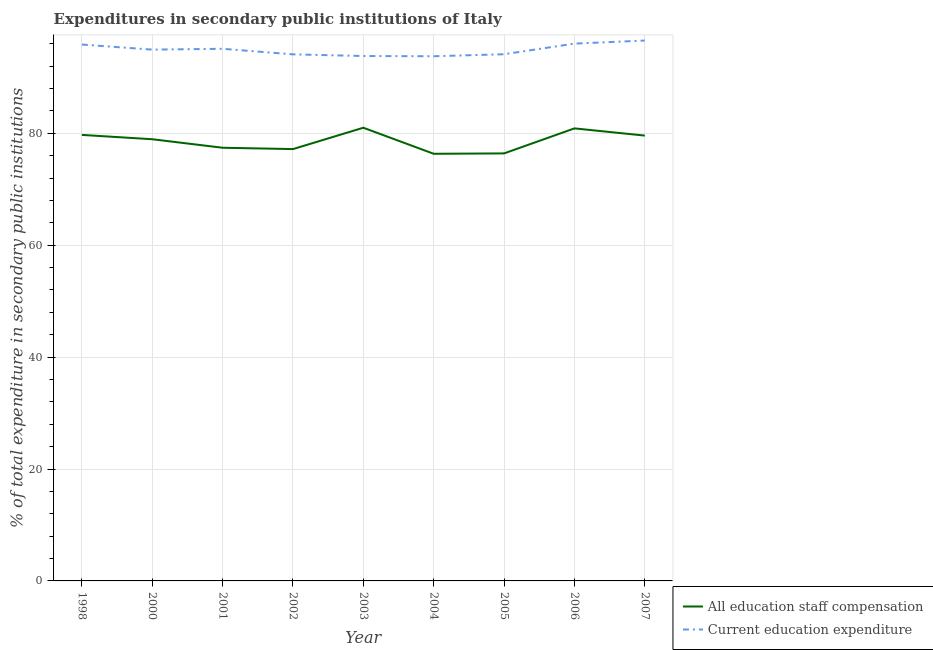Is the number of lines equal to the number of legend labels?
Keep it short and to the point. Yes. What is the expenditure in staff compensation in 2004?
Your response must be concise. 76.35. Across all years, what is the maximum expenditure in staff compensation?
Your answer should be very brief. 81. Across all years, what is the minimum expenditure in education?
Make the answer very short. 93.78. What is the total expenditure in staff compensation in the graph?
Make the answer very short. 707.53. What is the difference between the expenditure in staff compensation in 2001 and that in 2004?
Your answer should be compact. 1.08. What is the difference between the expenditure in staff compensation in 2004 and the expenditure in education in 2005?
Provide a short and direct response. -17.79. What is the average expenditure in staff compensation per year?
Offer a terse response. 78.61. In the year 2005, what is the difference between the expenditure in education and expenditure in staff compensation?
Your answer should be very brief. 17.73. What is the ratio of the expenditure in staff compensation in 2004 to that in 2006?
Offer a very short reply. 0.94. What is the difference between the highest and the second highest expenditure in education?
Provide a short and direct response. 0.55. What is the difference between the highest and the lowest expenditure in staff compensation?
Offer a terse response. 4.66. Is the sum of the expenditure in staff compensation in 2003 and 2007 greater than the maximum expenditure in education across all years?
Make the answer very short. Yes. Is the expenditure in education strictly greater than the expenditure in staff compensation over the years?
Provide a succinct answer. Yes. How many lines are there?
Provide a short and direct response. 2. What is the difference between two consecutive major ticks on the Y-axis?
Your response must be concise. 20. What is the title of the graph?
Offer a very short reply. Expenditures in secondary public institutions of Italy. What is the label or title of the Y-axis?
Provide a succinct answer. % of total expenditure in secondary public institutions. What is the % of total expenditure in secondary public institutions of All education staff compensation in 1998?
Keep it short and to the point. 79.72. What is the % of total expenditure in secondary public institutions of Current education expenditure in 1998?
Give a very brief answer. 95.87. What is the % of total expenditure in secondary public institutions in All education staff compensation in 2000?
Make the answer very short. 78.95. What is the % of total expenditure in secondary public institutions in Current education expenditure in 2000?
Give a very brief answer. 94.97. What is the % of total expenditure in secondary public institutions in All education staff compensation in 2001?
Your response must be concise. 77.43. What is the % of total expenditure in secondary public institutions of Current education expenditure in 2001?
Keep it short and to the point. 95.11. What is the % of total expenditure in secondary public institutions of All education staff compensation in 2002?
Offer a very short reply. 77.19. What is the % of total expenditure in secondary public institutions in Current education expenditure in 2002?
Keep it short and to the point. 94.12. What is the % of total expenditure in secondary public institutions of All education staff compensation in 2003?
Provide a short and direct response. 81. What is the % of total expenditure in secondary public institutions in Current education expenditure in 2003?
Provide a succinct answer. 93.82. What is the % of total expenditure in secondary public institutions of All education staff compensation in 2004?
Provide a succinct answer. 76.35. What is the % of total expenditure in secondary public institutions in Current education expenditure in 2004?
Offer a terse response. 93.78. What is the % of total expenditure in secondary public institutions of All education staff compensation in 2005?
Offer a terse response. 76.41. What is the % of total expenditure in secondary public institutions in Current education expenditure in 2005?
Your answer should be compact. 94.14. What is the % of total expenditure in secondary public institutions in All education staff compensation in 2006?
Keep it short and to the point. 80.89. What is the % of total expenditure in secondary public institutions in Current education expenditure in 2006?
Keep it short and to the point. 96.04. What is the % of total expenditure in secondary public institutions of All education staff compensation in 2007?
Give a very brief answer. 79.6. What is the % of total expenditure in secondary public institutions of Current education expenditure in 2007?
Provide a succinct answer. 96.59. Across all years, what is the maximum % of total expenditure in secondary public institutions of All education staff compensation?
Keep it short and to the point. 81. Across all years, what is the maximum % of total expenditure in secondary public institutions in Current education expenditure?
Your answer should be compact. 96.59. Across all years, what is the minimum % of total expenditure in secondary public institutions in All education staff compensation?
Provide a succinct answer. 76.35. Across all years, what is the minimum % of total expenditure in secondary public institutions in Current education expenditure?
Make the answer very short. 93.78. What is the total % of total expenditure in secondary public institutions of All education staff compensation in the graph?
Provide a succinct answer. 707.53. What is the total % of total expenditure in secondary public institutions of Current education expenditure in the graph?
Your response must be concise. 854.44. What is the difference between the % of total expenditure in secondary public institutions in All education staff compensation in 1998 and that in 2000?
Give a very brief answer. 0.77. What is the difference between the % of total expenditure in secondary public institutions of Current education expenditure in 1998 and that in 2000?
Your answer should be very brief. 0.91. What is the difference between the % of total expenditure in secondary public institutions in All education staff compensation in 1998 and that in 2001?
Offer a terse response. 2.29. What is the difference between the % of total expenditure in secondary public institutions of Current education expenditure in 1998 and that in 2001?
Provide a short and direct response. 0.76. What is the difference between the % of total expenditure in secondary public institutions of All education staff compensation in 1998 and that in 2002?
Your answer should be compact. 2.53. What is the difference between the % of total expenditure in secondary public institutions of Current education expenditure in 1998 and that in 2002?
Your answer should be compact. 1.75. What is the difference between the % of total expenditure in secondary public institutions of All education staff compensation in 1998 and that in 2003?
Offer a very short reply. -1.28. What is the difference between the % of total expenditure in secondary public institutions in Current education expenditure in 1998 and that in 2003?
Give a very brief answer. 2.05. What is the difference between the % of total expenditure in secondary public institutions in All education staff compensation in 1998 and that in 2004?
Ensure brevity in your answer.  3.37. What is the difference between the % of total expenditure in secondary public institutions in Current education expenditure in 1998 and that in 2004?
Provide a short and direct response. 2.09. What is the difference between the % of total expenditure in secondary public institutions in All education staff compensation in 1998 and that in 2005?
Your answer should be very brief. 3.31. What is the difference between the % of total expenditure in secondary public institutions of Current education expenditure in 1998 and that in 2005?
Provide a short and direct response. 1.73. What is the difference between the % of total expenditure in secondary public institutions in All education staff compensation in 1998 and that in 2006?
Your answer should be very brief. -1.17. What is the difference between the % of total expenditure in secondary public institutions in Current education expenditure in 1998 and that in 2006?
Provide a succinct answer. -0.16. What is the difference between the % of total expenditure in secondary public institutions of All education staff compensation in 1998 and that in 2007?
Make the answer very short. 0.12. What is the difference between the % of total expenditure in secondary public institutions of Current education expenditure in 1998 and that in 2007?
Make the answer very short. -0.72. What is the difference between the % of total expenditure in secondary public institutions in All education staff compensation in 2000 and that in 2001?
Provide a short and direct response. 1.52. What is the difference between the % of total expenditure in secondary public institutions of Current education expenditure in 2000 and that in 2001?
Your answer should be very brief. -0.15. What is the difference between the % of total expenditure in secondary public institutions of All education staff compensation in 2000 and that in 2002?
Your answer should be very brief. 1.76. What is the difference between the % of total expenditure in secondary public institutions in Current education expenditure in 2000 and that in 2002?
Your answer should be compact. 0.84. What is the difference between the % of total expenditure in secondary public institutions in All education staff compensation in 2000 and that in 2003?
Your answer should be compact. -2.06. What is the difference between the % of total expenditure in secondary public institutions of Current education expenditure in 2000 and that in 2003?
Offer a very short reply. 1.14. What is the difference between the % of total expenditure in secondary public institutions in All education staff compensation in 2000 and that in 2004?
Your response must be concise. 2.6. What is the difference between the % of total expenditure in secondary public institutions of Current education expenditure in 2000 and that in 2004?
Provide a short and direct response. 1.18. What is the difference between the % of total expenditure in secondary public institutions of All education staff compensation in 2000 and that in 2005?
Your response must be concise. 2.53. What is the difference between the % of total expenditure in secondary public institutions in Current education expenditure in 2000 and that in 2005?
Ensure brevity in your answer.  0.82. What is the difference between the % of total expenditure in secondary public institutions of All education staff compensation in 2000 and that in 2006?
Provide a succinct answer. -1.94. What is the difference between the % of total expenditure in secondary public institutions of Current education expenditure in 2000 and that in 2006?
Offer a terse response. -1.07. What is the difference between the % of total expenditure in secondary public institutions of All education staff compensation in 2000 and that in 2007?
Offer a terse response. -0.65. What is the difference between the % of total expenditure in secondary public institutions of Current education expenditure in 2000 and that in 2007?
Offer a very short reply. -1.62. What is the difference between the % of total expenditure in secondary public institutions of All education staff compensation in 2001 and that in 2002?
Your response must be concise. 0.24. What is the difference between the % of total expenditure in secondary public institutions of All education staff compensation in 2001 and that in 2003?
Ensure brevity in your answer.  -3.58. What is the difference between the % of total expenditure in secondary public institutions in Current education expenditure in 2001 and that in 2003?
Keep it short and to the point. 1.29. What is the difference between the % of total expenditure in secondary public institutions of All education staff compensation in 2001 and that in 2004?
Provide a short and direct response. 1.08. What is the difference between the % of total expenditure in secondary public institutions of Current education expenditure in 2001 and that in 2004?
Provide a succinct answer. 1.33. What is the difference between the % of total expenditure in secondary public institutions of All education staff compensation in 2001 and that in 2005?
Provide a succinct answer. 1.01. What is the difference between the % of total expenditure in secondary public institutions in Current education expenditure in 2001 and that in 2005?
Provide a succinct answer. 0.97. What is the difference between the % of total expenditure in secondary public institutions of All education staff compensation in 2001 and that in 2006?
Keep it short and to the point. -3.46. What is the difference between the % of total expenditure in secondary public institutions of Current education expenditure in 2001 and that in 2006?
Your answer should be compact. -0.92. What is the difference between the % of total expenditure in secondary public institutions of All education staff compensation in 2001 and that in 2007?
Offer a very short reply. -2.17. What is the difference between the % of total expenditure in secondary public institutions in Current education expenditure in 2001 and that in 2007?
Offer a terse response. -1.48. What is the difference between the % of total expenditure in secondary public institutions in All education staff compensation in 2002 and that in 2003?
Give a very brief answer. -3.82. What is the difference between the % of total expenditure in secondary public institutions in Current education expenditure in 2002 and that in 2003?
Give a very brief answer. 0.3. What is the difference between the % of total expenditure in secondary public institutions in All education staff compensation in 2002 and that in 2004?
Keep it short and to the point. 0.84. What is the difference between the % of total expenditure in secondary public institutions of Current education expenditure in 2002 and that in 2004?
Make the answer very short. 0.34. What is the difference between the % of total expenditure in secondary public institutions of All education staff compensation in 2002 and that in 2005?
Make the answer very short. 0.77. What is the difference between the % of total expenditure in secondary public institutions in Current education expenditure in 2002 and that in 2005?
Offer a very short reply. -0.02. What is the difference between the % of total expenditure in secondary public institutions of All education staff compensation in 2002 and that in 2006?
Give a very brief answer. -3.7. What is the difference between the % of total expenditure in secondary public institutions in Current education expenditure in 2002 and that in 2006?
Ensure brevity in your answer.  -1.91. What is the difference between the % of total expenditure in secondary public institutions of All education staff compensation in 2002 and that in 2007?
Make the answer very short. -2.41. What is the difference between the % of total expenditure in secondary public institutions of Current education expenditure in 2002 and that in 2007?
Your answer should be very brief. -2.47. What is the difference between the % of total expenditure in secondary public institutions of All education staff compensation in 2003 and that in 2004?
Provide a short and direct response. 4.66. What is the difference between the % of total expenditure in secondary public institutions in Current education expenditure in 2003 and that in 2004?
Your response must be concise. 0.04. What is the difference between the % of total expenditure in secondary public institutions in All education staff compensation in 2003 and that in 2005?
Offer a terse response. 4.59. What is the difference between the % of total expenditure in secondary public institutions of Current education expenditure in 2003 and that in 2005?
Provide a short and direct response. -0.32. What is the difference between the % of total expenditure in secondary public institutions in All education staff compensation in 2003 and that in 2006?
Your answer should be very brief. 0.12. What is the difference between the % of total expenditure in secondary public institutions of Current education expenditure in 2003 and that in 2006?
Your answer should be compact. -2.22. What is the difference between the % of total expenditure in secondary public institutions of All education staff compensation in 2003 and that in 2007?
Your answer should be very brief. 1.4. What is the difference between the % of total expenditure in secondary public institutions in Current education expenditure in 2003 and that in 2007?
Your response must be concise. -2.77. What is the difference between the % of total expenditure in secondary public institutions in All education staff compensation in 2004 and that in 2005?
Provide a short and direct response. -0.07. What is the difference between the % of total expenditure in secondary public institutions of Current education expenditure in 2004 and that in 2005?
Provide a succinct answer. -0.36. What is the difference between the % of total expenditure in secondary public institutions of All education staff compensation in 2004 and that in 2006?
Offer a terse response. -4.54. What is the difference between the % of total expenditure in secondary public institutions of Current education expenditure in 2004 and that in 2006?
Your answer should be very brief. -2.26. What is the difference between the % of total expenditure in secondary public institutions of All education staff compensation in 2004 and that in 2007?
Your answer should be compact. -3.25. What is the difference between the % of total expenditure in secondary public institutions of Current education expenditure in 2004 and that in 2007?
Your answer should be very brief. -2.81. What is the difference between the % of total expenditure in secondary public institutions in All education staff compensation in 2005 and that in 2006?
Offer a very short reply. -4.47. What is the difference between the % of total expenditure in secondary public institutions in Current education expenditure in 2005 and that in 2006?
Provide a succinct answer. -1.89. What is the difference between the % of total expenditure in secondary public institutions in All education staff compensation in 2005 and that in 2007?
Provide a short and direct response. -3.19. What is the difference between the % of total expenditure in secondary public institutions in Current education expenditure in 2005 and that in 2007?
Offer a very short reply. -2.45. What is the difference between the % of total expenditure in secondary public institutions in All education staff compensation in 2006 and that in 2007?
Keep it short and to the point. 1.29. What is the difference between the % of total expenditure in secondary public institutions of Current education expenditure in 2006 and that in 2007?
Offer a very short reply. -0.55. What is the difference between the % of total expenditure in secondary public institutions of All education staff compensation in 1998 and the % of total expenditure in secondary public institutions of Current education expenditure in 2000?
Provide a short and direct response. -15.24. What is the difference between the % of total expenditure in secondary public institutions in All education staff compensation in 1998 and the % of total expenditure in secondary public institutions in Current education expenditure in 2001?
Keep it short and to the point. -15.39. What is the difference between the % of total expenditure in secondary public institutions in All education staff compensation in 1998 and the % of total expenditure in secondary public institutions in Current education expenditure in 2002?
Your answer should be compact. -14.4. What is the difference between the % of total expenditure in secondary public institutions of All education staff compensation in 1998 and the % of total expenditure in secondary public institutions of Current education expenditure in 2003?
Keep it short and to the point. -14.1. What is the difference between the % of total expenditure in secondary public institutions of All education staff compensation in 1998 and the % of total expenditure in secondary public institutions of Current education expenditure in 2004?
Offer a terse response. -14.06. What is the difference between the % of total expenditure in secondary public institutions of All education staff compensation in 1998 and the % of total expenditure in secondary public institutions of Current education expenditure in 2005?
Your answer should be compact. -14.42. What is the difference between the % of total expenditure in secondary public institutions in All education staff compensation in 1998 and the % of total expenditure in secondary public institutions in Current education expenditure in 2006?
Ensure brevity in your answer.  -16.32. What is the difference between the % of total expenditure in secondary public institutions in All education staff compensation in 1998 and the % of total expenditure in secondary public institutions in Current education expenditure in 2007?
Your response must be concise. -16.87. What is the difference between the % of total expenditure in secondary public institutions in All education staff compensation in 2000 and the % of total expenditure in secondary public institutions in Current education expenditure in 2001?
Your response must be concise. -16.16. What is the difference between the % of total expenditure in secondary public institutions in All education staff compensation in 2000 and the % of total expenditure in secondary public institutions in Current education expenditure in 2002?
Provide a short and direct response. -15.17. What is the difference between the % of total expenditure in secondary public institutions in All education staff compensation in 2000 and the % of total expenditure in secondary public institutions in Current education expenditure in 2003?
Keep it short and to the point. -14.87. What is the difference between the % of total expenditure in secondary public institutions in All education staff compensation in 2000 and the % of total expenditure in secondary public institutions in Current education expenditure in 2004?
Give a very brief answer. -14.83. What is the difference between the % of total expenditure in secondary public institutions of All education staff compensation in 2000 and the % of total expenditure in secondary public institutions of Current education expenditure in 2005?
Make the answer very short. -15.19. What is the difference between the % of total expenditure in secondary public institutions of All education staff compensation in 2000 and the % of total expenditure in secondary public institutions of Current education expenditure in 2006?
Offer a terse response. -17.09. What is the difference between the % of total expenditure in secondary public institutions of All education staff compensation in 2000 and the % of total expenditure in secondary public institutions of Current education expenditure in 2007?
Your response must be concise. -17.64. What is the difference between the % of total expenditure in secondary public institutions in All education staff compensation in 2001 and the % of total expenditure in secondary public institutions in Current education expenditure in 2002?
Keep it short and to the point. -16.7. What is the difference between the % of total expenditure in secondary public institutions of All education staff compensation in 2001 and the % of total expenditure in secondary public institutions of Current education expenditure in 2003?
Your response must be concise. -16.39. What is the difference between the % of total expenditure in secondary public institutions in All education staff compensation in 2001 and the % of total expenditure in secondary public institutions in Current education expenditure in 2004?
Provide a succinct answer. -16.35. What is the difference between the % of total expenditure in secondary public institutions in All education staff compensation in 2001 and the % of total expenditure in secondary public institutions in Current education expenditure in 2005?
Provide a short and direct response. -16.72. What is the difference between the % of total expenditure in secondary public institutions in All education staff compensation in 2001 and the % of total expenditure in secondary public institutions in Current education expenditure in 2006?
Offer a very short reply. -18.61. What is the difference between the % of total expenditure in secondary public institutions in All education staff compensation in 2001 and the % of total expenditure in secondary public institutions in Current education expenditure in 2007?
Keep it short and to the point. -19.16. What is the difference between the % of total expenditure in secondary public institutions in All education staff compensation in 2002 and the % of total expenditure in secondary public institutions in Current education expenditure in 2003?
Provide a succinct answer. -16.63. What is the difference between the % of total expenditure in secondary public institutions of All education staff compensation in 2002 and the % of total expenditure in secondary public institutions of Current education expenditure in 2004?
Offer a very short reply. -16.59. What is the difference between the % of total expenditure in secondary public institutions in All education staff compensation in 2002 and the % of total expenditure in secondary public institutions in Current education expenditure in 2005?
Keep it short and to the point. -16.95. What is the difference between the % of total expenditure in secondary public institutions of All education staff compensation in 2002 and the % of total expenditure in secondary public institutions of Current education expenditure in 2006?
Keep it short and to the point. -18.85. What is the difference between the % of total expenditure in secondary public institutions in All education staff compensation in 2002 and the % of total expenditure in secondary public institutions in Current education expenditure in 2007?
Provide a succinct answer. -19.4. What is the difference between the % of total expenditure in secondary public institutions of All education staff compensation in 2003 and the % of total expenditure in secondary public institutions of Current education expenditure in 2004?
Offer a terse response. -12.78. What is the difference between the % of total expenditure in secondary public institutions of All education staff compensation in 2003 and the % of total expenditure in secondary public institutions of Current education expenditure in 2005?
Offer a terse response. -13.14. What is the difference between the % of total expenditure in secondary public institutions in All education staff compensation in 2003 and the % of total expenditure in secondary public institutions in Current education expenditure in 2006?
Offer a very short reply. -15.03. What is the difference between the % of total expenditure in secondary public institutions in All education staff compensation in 2003 and the % of total expenditure in secondary public institutions in Current education expenditure in 2007?
Offer a very short reply. -15.59. What is the difference between the % of total expenditure in secondary public institutions of All education staff compensation in 2004 and the % of total expenditure in secondary public institutions of Current education expenditure in 2005?
Offer a terse response. -17.79. What is the difference between the % of total expenditure in secondary public institutions of All education staff compensation in 2004 and the % of total expenditure in secondary public institutions of Current education expenditure in 2006?
Offer a very short reply. -19.69. What is the difference between the % of total expenditure in secondary public institutions in All education staff compensation in 2004 and the % of total expenditure in secondary public institutions in Current education expenditure in 2007?
Offer a very short reply. -20.24. What is the difference between the % of total expenditure in secondary public institutions of All education staff compensation in 2005 and the % of total expenditure in secondary public institutions of Current education expenditure in 2006?
Give a very brief answer. -19.62. What is the difference between the % of total expenditure in secondary public institutions of All education staff compensation in 2005 and the % of total expenditure in secondary public institutions of Current education expenditure in 2007?
Your answer should be very brief. -20.17. What is the difference between the % of total expenditure in secondary public institutions of All education staff compensation in 2006 and the % of total expenditure in secondary public institutions of Current education expenditure in 2007?
Keep it short and to the point. -15.7. What is the average % of total expenditure in secondary public institutions of All education staff compensation per year?
Ensure brevity in your answer.  78.61. What is the average % of total expenditure in secondary public institutions of Current education expenditure per year?
Give a very brief answer. 94.94. In the year 1998, what is the difference between the % of total expenditure in secondary public institutions of All education staff compensation and % of total expenditure in secondary public institutions of Current education expenditure?
Give a very brief answer. -16.15. In the year 2000, what is the difference between the % of total expenditure in secondary public institutions in All education staff compensation and % of total expenditure in secondary public institutions in Current education expenditure?
Offer a very short reply. -16.02. In the year 2001, what is the difference between the % of total expenditure in secondary public institutions in All education staff compensation and % of total expenditure in secondary public institutions in Current education expenditure?
Make the answer very short. -17.69. In the year 2002, what is the difference between the % of total expenditure in secondary public institutions of All education staff compensation and % of total expenditure in secondary public institutions of Current education expenditure?
Give a very brief answer. -16.93. In the year 2003, what is the difference between the % of total expenditure in secondary public institutions of All education staff compensation and % of total expenditure in secondary public institutions of Current education expenditure?
Ensure brevity in your answer.  -12.82. In the year 2004, what is the difference between the % of total expenditure in secondary public institutions in All education staff compensation and % of total expenditure in secondary public institutions in Current education expenditure?
Make the answer very short. -17.43. In the year 2005, what is the difference between the % of total expenditure in secondary public institutions of All education staff compensation and % of total expenditure in secondary public institutions of Current education expenditure?
Your answer should be compact. -17.73. In the year 2006, what is the difference between the % of total expenditure in secondary public institutions of All education staff compensation and % of total expenditure in secondary public institutions of Current education expenditure?
Keep it short and to the point. -15.15. In the year 2007, what is the difference between the % of total expenditure in secondary public institutions in All education staff compensation and % of total expenditure in secondary public institutions in Current education expenditure?
Your response must be concise. -16.99. What is the ratio of the % of total expenditure in secondary public institutions in All education staff compensation in 1998 to that in 2000?
Offer a very short reply. 1.01. What is the ratio of the % of total expenditure in secondary public institutions of Current education expenditure in 1998 to that in 2000?
Make the answer very short. 1.01. What is the ratio of the % of total expenditure in secondary public institutions of All education staff compensation in 1998 to that in 2001?
Offer a very short reply. 1.03. What is the ratio of the % of total expenditure in secondary public institutions in Current education expenditure in 1998 to that in 2001?
Ensure brevity in your answer.  1.01. What is the ratio of the % of total expenditure in secondary public institutions of All education staff compensation in 1998 to that in 2002?
Ensure brevity in your answer.  1.03. What is the ratio of the % of total expenditure in secondary public institutions in Current education expenditure in 1998 to that in 2002?
Your answer should be very brief. 1.02. What is the ratio of the % of total expenditure in secondary public institutions of All education staff compensation in 1998 to that in 2003?
Give a very brief answer. 0.98. What is the ratio of the % of total expenditure in secondary public institutions of Current education expenditure in 1998 to that in 2003?
Your answer should be compact. 1.02. What is the ratio of the % of total expenditure in secondary public institutions in All education staff compensation in 1998 to that in 2004?
Make the answer very short. 1.04. What is the ratio of the % of total expenditure in secondary public institutions in Current education expenditure in 1998 to that in 2004?
Offer a terse response. 1.02. What is the ratio of the % of total expenditure in secondary public institutions in All education staff compensation in 1998 to that in 2005?
Your answer should be very brief. 1.04. What is the ratio of the % of total expenditure in secondary public institutions of Current education expenditure in 1998 to that in 2005?
Keep it short and to the point. 1.02. What is the ratio of the % of total expenditure in secondary public institutions of All education staff compensation in 1998 to that in 2006?
Give a very brief answer. 0.99. What is the ratio of the % of total expenditure in secondary public institutions of Current education expenditure in 1998 to that in 2006?
Your answer should be compact. 1. What is the ratio of the % of total expenditure in secondary public institutions in All education staff compensation in 1998 to that in 2007?
Your answer should be compact. 1. What is the ratio of the % of total expenditure in secondary public institutions of Current education expenditure in 1998 to that in 2007?
Your answer should be very brief. 0.99. What is the ratio of the % of total expenditure in secondary public institutions in All education staff compensation in 2000 to that in 2001?
Give a very brief answer. 1.02. What is the ratio of the % of total expenditure in secondary public institutions in All education staff compensation in 2000 to that in 2002?
Provide a succinct answer. 1.02. What is the ratio of the % of total expenditure in secondary public institutions in All education staff compensation in 2000 to that in 2003?
Provide a succinct answer. 0.97. What is the ratio of the % of total expenditure in secondary public institutions of Current education expenditure in 2000 to that in 2003?
Offer a terse response. 1.01. What is the ratio of the % of total expenditure in secondary public institutions of All education staff compensation in 2000 to that in 2004?
Ensure brevity in your answer.  1.03. What is the ratio of the % of total expenditure in secondary public institutions of Current education expenditure in 2000 to that in 2004?
Give a very brief answer. 1.01. What is the ratio of the % of total expenditure in secondary public institutions of All education staff compensation in 2000 to that in 2005?
Provide a succinct answer. 1.03. What is the ratio of the % of total expenditure in secondary public institutions of Current education expenditure in 2000 to that in 2005?
Provide a succinct answer. 1.01. What is the ratio of the % of total expenditure in secondary public institutions of All education staff compensation in 2000 to that in 2006?
Make the answer very short. 0.98. What is the ratio of the % of total expenditure in secondary public institutions in Current education expenditure in 2000 to that in 2006?
Offer a terse response. 0.99. What is the ratio of the % of total expenditure in secondary public institutions of Current education expenditure in 2000 to that in 2007?
Offer a very short reply. 0.98. What is the ratio of the % of total expenditure in secondary public institutions of Current education expenditure in 2001 to that in 2002?
Give a very brief answer. 1.01. What is the ratio of the % of total expenditure in secondary public institutions in All education staff compensation in 2001 to that in 2003?
Offer a terse response. 0.96. What is the ratio of the % of total expenditure in secondary public institutions of Current education expenditure in 2001 to that in 2003?
Your answer should be compact. 1.01. What is the ratio of the % of total expenditure in secondary public institutions in All education staff compensation in 2001 to that in 2004?
Offer a very short reply. 1.01. What is the ratio of the % of total expenditure in secondary public institutions of Current education expenditure in 2001 to that in 2004?
Offer a terse response. 1.01. What is the ratio of the % of total expenditure in secondary public institutions of All education staff compensation in 2001 to that in 2005?
Provide a short and direct response. 1.01. What is the ratio of the % of total expenditure in secondary public institutions of Current education expenditure in 2001 to that in 2005?
Make the answer very short. 1.01. What is the ratio of the % of total expenditure in secondary public institutions in All education staff compensation in 2001 to that in 2006?
Give a very brief answer. 0.96. What is the ratio of the % of total expenditure in secondary public institutions in All education staff compensation in 2001 to that in 2007?
Your answer should be compact. 0.97. What is the ratio of the % of total expenditure in secondary public institutions of Current education expenditure in 2001 to that in 2007?
Your response must be concise. 0.98. What is the ratio of the % of total expenditure in secondary public institutions of All education staff compensation in 2002 to that in 2003?
Make the answer very short. 0.95. What is the ratio of the % of total expenditure in secondary public institutions in All education staff compensation in 2002 to that in 2004?
Provide a short and direct response. 1.01. What is the ratio of the % of total expenditure in secondary public institutions in All education staff compensation in 2002 to that in 2005?
Make the answer very short. 1.01. What is the ratio of the % of total expenditure in secondary public institutions of Current education expenditure in 2002 to that in 2005?
Your answer should be compact. 1. What is the ratio of the % of total expenditure in secondary public institutions in All education staff compensation in 2002 to that in 2006?
Offer a terse response. 0.95. What is the ratio of the % of total expenditure in secondary public institutions in Current education expenditure in 2002 to that in 2006?
Provide a succinct answer. 0.98. What is the ratio of the % of total expenditure in secondary public institutions of All education staff compensation in 2002 to that in 2007?
Your answer should be compact. 0.97. What is the ratio of the % of total expenditure in secondary public institutions in Current education expenditure in 2002 to that in 2007?
Your answer should be compact. 0.97. What is the ratio of the % of total expenditure in secondary public institutions in All education staff compensation in 2003 to that in 2004?
Ensure brevity in your answer.  1.06. What is the ratio of the % of total expenditure in secondary public institutions of Current education expenditure in 2003 to that in 2004?
Keep it short and to the point. 1. What is the ratio of the % of total expenditure in secondary public institutions in All education staff compensation in 2003 to that in 2005?
Keep it short and to the point. 1.06. What is the ratio of the % of total expenditure in secondary public institutions in Current education expenditure in 2003 to that in 2005?
Provide a short and direct response. 1. What is the ratio of the % of total expenditure in secondary public institutions of Current education expenditure in 2003 to that in 2006?
Make the answer very short. 0.98. What is the ratio of the % of total expenditure in secondary public institutions in All education staff compensation in 2003 to that in 2007?
Keep it short and to the point. 1.02. What is the ratio of the % of total expenditure in secondary public institutions in Current education expenditure in 2003 to that in 2007?
Your answer should be compact. 0.97. What is the ratio of the % of total expenditure in secondary public institutions of All education staff compensation in 2004 to that in 2006?
Offer a terse response. 0.94. What is the ratio of the % of total expenditure in secondary public institutions of Current education expenditure in 2004 to that in 2006?
Give a very brief answer. 0.98. What is the ratio of the % of total expenditure in secondary public institutions in All education staff compensation in 2004 to that in 2007?
Ensure brevity in your answer.  0.96. What is the ratio of the % of total expenditure in secondary public institutions in Current education expenditure in 2004 to that in 2007?
Your response must be concise. 0.97. What is the ratio of the % of total expenditure in secondary public institutions in All education staff compensation in 2005 to that in 2006?
Offer a very short reply. 0.94. What is the ratio of the % of total expenditure in secondary public institutions of Current education expenditure in 2005 to that in 2006?
Give a very brief answer. 0.98. What is the ratio of the % of total expenditure in secondary public institutions in All education staff compensation in 2005 to that in 2007?
Your answer should be very brief. 0.96. What is the ratio of the % of total expenditure in secondary public institutions in Current education expenditure in 2005 to that in 2007?
Offer a very short reply. 0.97. What is the ratio of the % of total expenditure in secondary public institutions of All education staff compensation in 2006 to that in 2007?
Offer a terse response. 1.02. What is the difference between the highest and the second highest % of total expenditure in secondary public institutions in All education staff compensation?
Your answer should be compact. 0.12. What is the difference between the highest and the second highest % of total expenditure in secondary public institutions of Current education expenditure?
Ensure brevity in your answer.  0.55. What is the difference between the highest and the lowest % of total expenditure in secondary public institutions of All education staff compensation?
Keep it short and to the point. 4.66. What is the difference between the highest and the lowest % of total expenditure in secondary public institutions of Current education expenditure?
Your answer should be very brief. 2.81. 